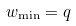<formula> <loc_0><loc_0><loc_500><loc_500>w _ { \min } = q</formula> 